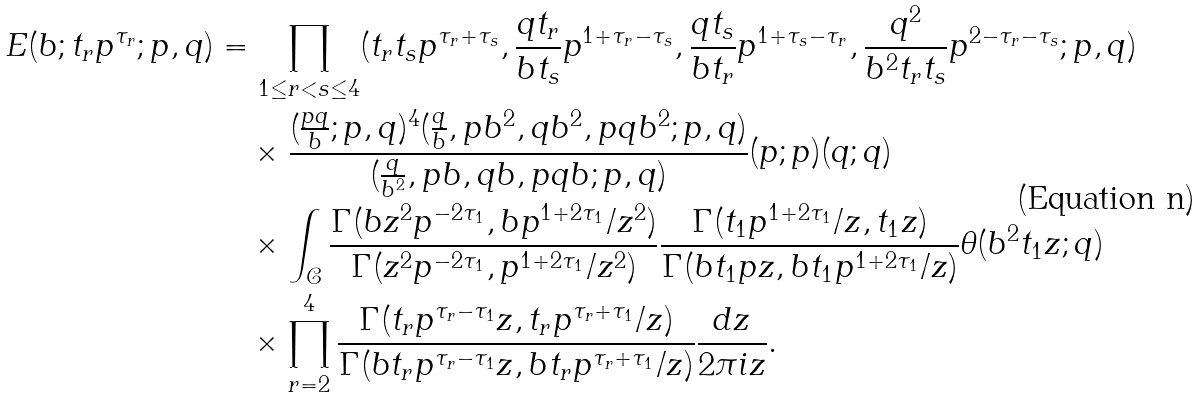Convert formula to latex. <formula><loc_0><loc_0><loc_500><loc_500>E ( b ; t _ { r } p ^ { \tau _ { r } } ; p , q ) & = \prod _ { 1 \leq r < s \leq 4 } ( t _ { r } t _ { s } p ^ { \tau _ { r } + \tau _ { s } } , \frac { q t _ { r } } { b t _ { s } } p ^ { 1 + \tau _ { r } - \tau _ { s } } , \frac { q t _ { s } } { b t _ { r } } p ^ { 1 + \tau _ { s } - \tau _ { r } } , \frac { q ^ { 2 } } { b ^ { 2 } t _ { r } t _ { s } } p ^ { 2 - \tau _ { r } - \tau _ { s } } ; p , q ) \\ & \quad \times \frac { ( \frac { p q } { b } ; p , q ) ^ { 4 } ( \frac { q } { b } , p b ^ { 2 } , q b ^ { 2 } , p q b ^ { 2 } ; p , q ) } { ( \frac { q } { b ^ { 2 } } , p b , q b , p q b ; p , q ) } ( p ; p ) ( q ; q ) \\ & \quad \times \int _ { \mathcal { C } } \frac { \Gamma ( b z ^ { 2 } p ^ { - 2 \tau _ { 1 } } , b p ^ { 1 + 2 \tau _ { 1 } } / z ^ { 2 } ) } { \Gamma ( z ^ { 2 } p ^ { - 2 \tau _ { 1 } } , p ^ { 1 + 2 \tau _ { 1 } } / z ^ { 2 } ) } \frac { \Gamma ( t _ { 1 } p ^ { 1 + 2 \tau _ { 1 } } / z , t _ { 1 } z ) } { \Gamma ( b t _ { 1 } p z , b t _ { 1 } p ^ { 1 + 2 \tau _ { 1 } } / z ) } \theta ( b ^ { 2 } t _ { 1 } z ; q ) \\ & \quad \times \prod _ { r = 2 } ^ { 4 } \frac { \Gamma ( t _ { r } p ^ { \tau _ { r } - \tau _ { 1 } } z , t _ { r } p ^ { \tau _ { r } + \tau _ { 1 } } / z ) } { \Gamma ( b t _ { r } p ^ { \tau _ { r } - \tau _ { 1 } } z , b t _ { r } p ^ { \tau _ { r } + \tau _ { 1 } } / z ) } \frac { d z } { 2 \pi i z } .</formula> 